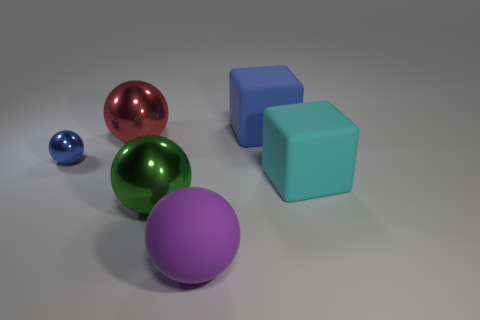Subtract all yellow balls. Subtract all red blocks. How many balls are left? 4 Add 1 blue things. How many objects exist? 7 Subtract all blocks. How many objects are left? 4 Subtract all large green blocks. Subtract all purple matte things. How many objects are left? 5 Add 1 cubes. How many cubes are left? 3 Add 5 large objects. How many large objects exist? 10 Subtract 1 green balls. How many objects are left? 5 